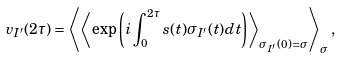<formula> <loc_0><loc_0><loc_500><loc_500>v _ { I ^ { \prime } } ( 2 \tau ) = \left \langle \left \langle \exp { \left ( i \int _ { 0 } ^ { 2 \tau } s ( t ) \sigma _ { I ^ { \prime } } ( t ) d t \right ) } \right \rangle _ { \sigma _ { I ^ { \prime } } ( 0 ) = \sigma } \right \rangle _ { \sigma } ,</formula> 